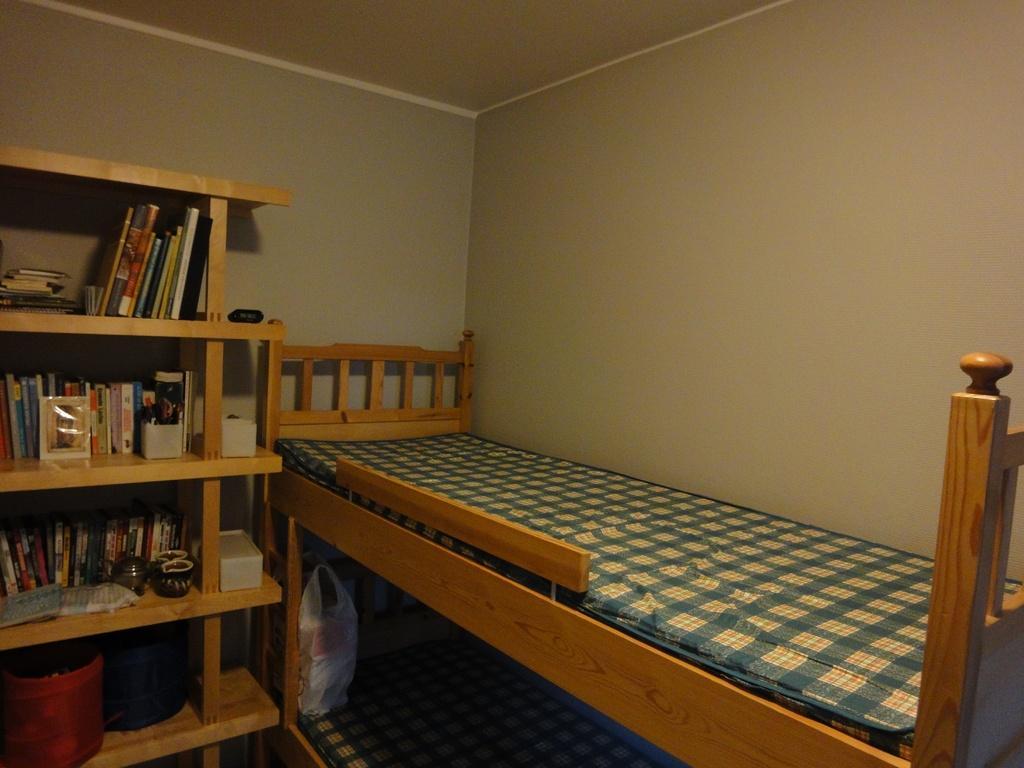In one or two sentences, can you explain what this image depicts? In this image I can see a bed with blue color. To the left there is a cupboard. In side the cupboard there are many books,cups and baskets. At the down there is a another bed and a cover on it. In the back there's a wall. 